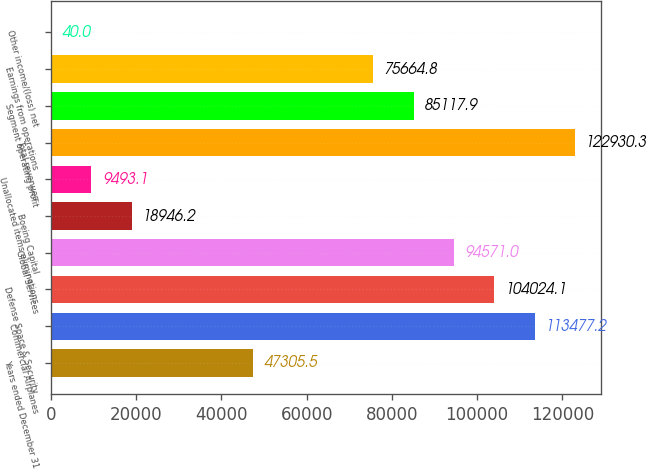Convert chart. <chart><loc_0><loc_0><loc_500><loc_500><bar_chart><fcel>Years ended December 31<fcel>Commercial Airplanes<fcel>Defense Space & Security<fcel>Global Services<fcel>Boeing Capital<fcel>Unallocated items eliminations<fcel>Total revenues<fcel>Segment operating profit<fcel>Earnings from operations<fcel>Other income/(loss) net<nl><fcel>47305.5<fcel>113477<fcel>104024<fcel>94571<fcel>18946.2<fcel>9493.1<fcel>122930<fcel>85117.9<fcel>75664.8<fcel>40<nl></chart> 